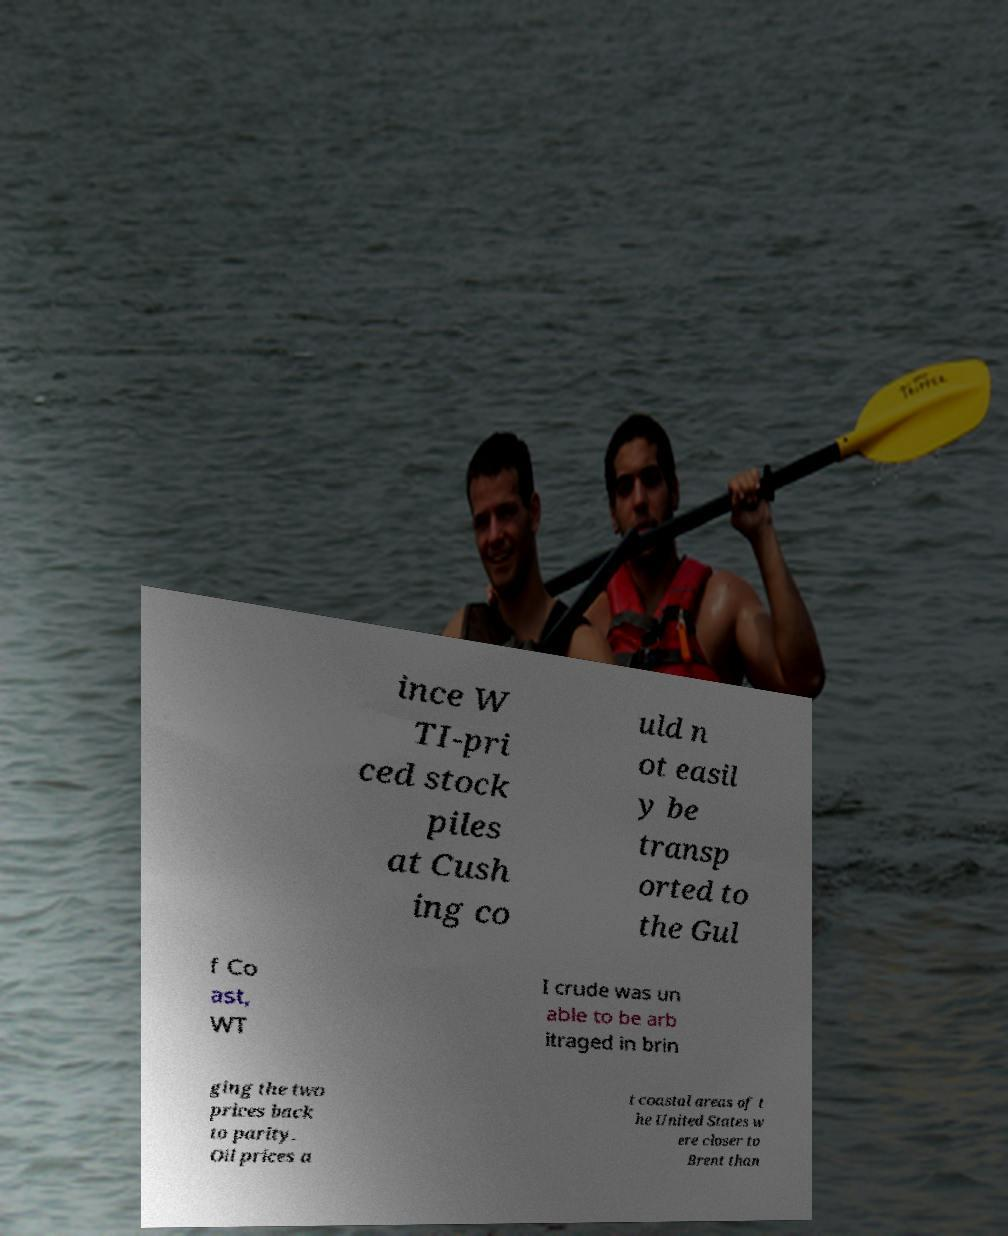For documentation purposes, I need the text within this image transcribed. Could you provide that? ince W TI-pri ced stock piles at Cush ing co uld n ot easil y be transp orted to the Gul f Co ast, WT I crude was un able to be arb itraged in brin ging the two prices back to parity. Oil prices a t coastal areas of t he United States w ere closer to Brent than 